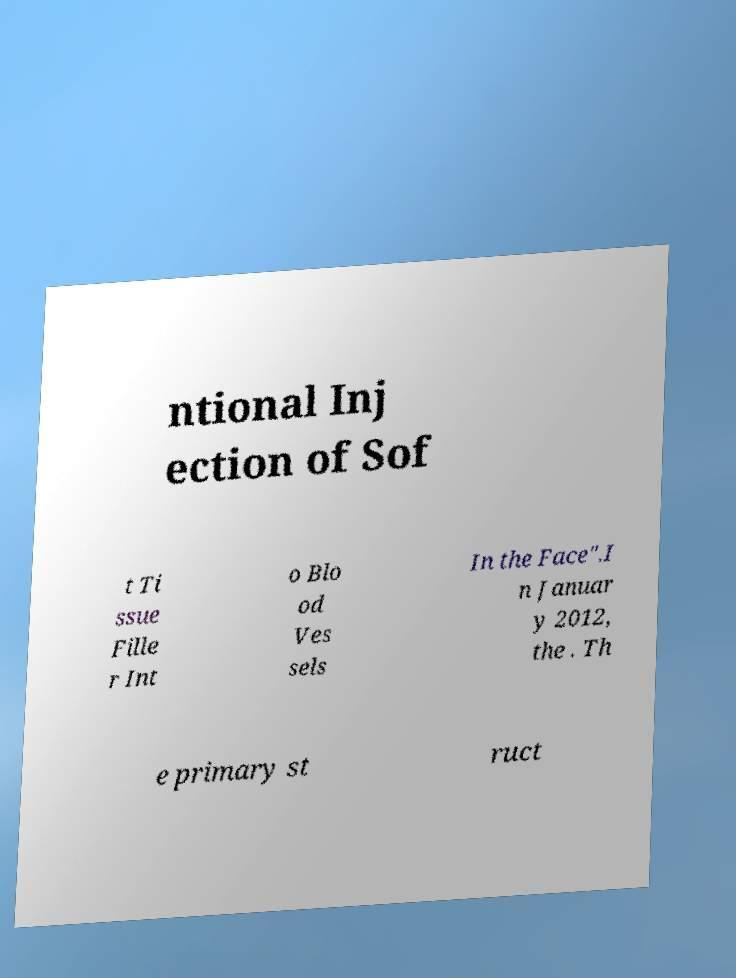There's text embedded in this image that I need extracted. Can you transcribe it verbatim? ntional Inj ection of Sof t Ti ssue Fille r Int o Blo od Ves sels In the Face".I n Januar y 2012, the . Th e primary st ruct 